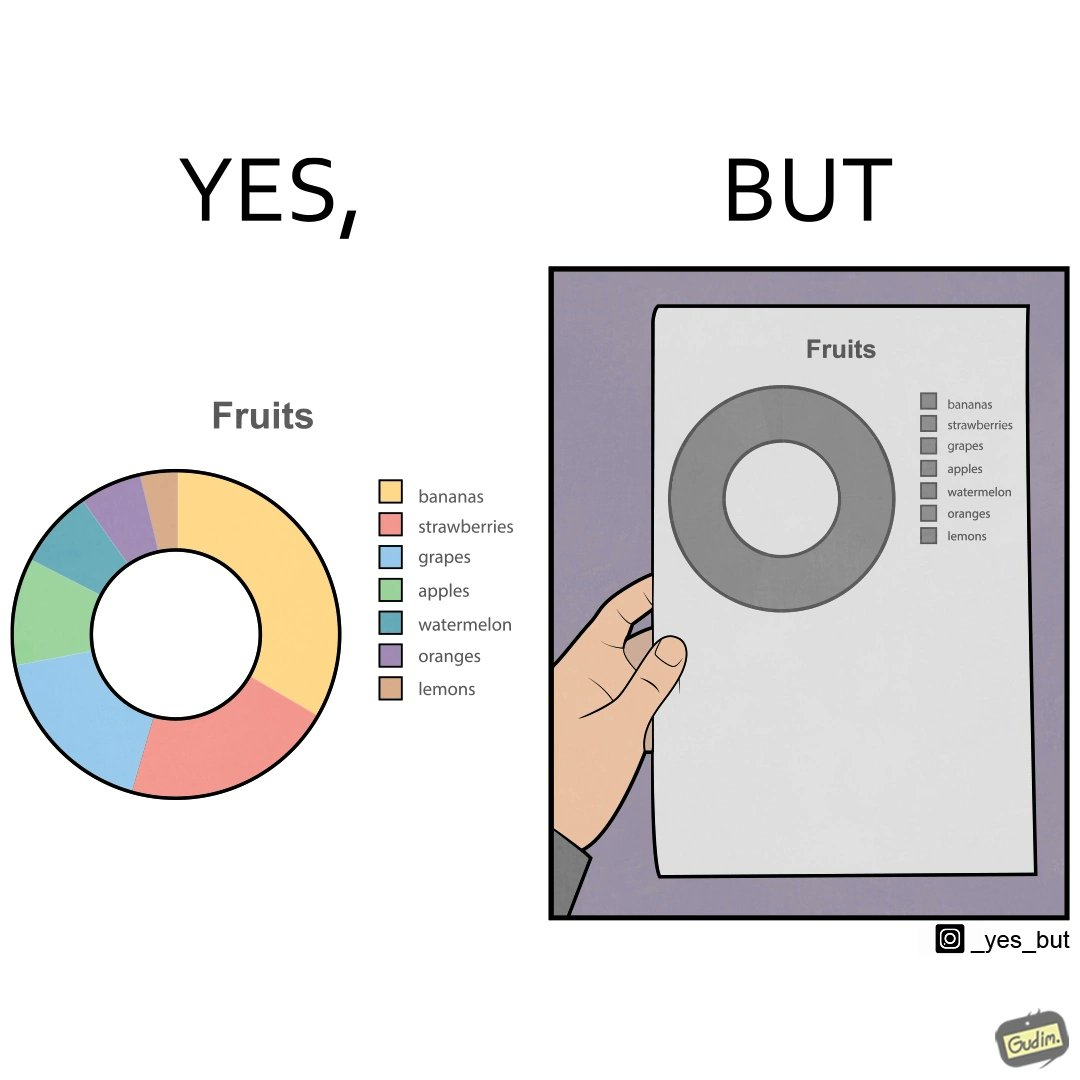Is this a satirical image? Yes, this image is satirical. 